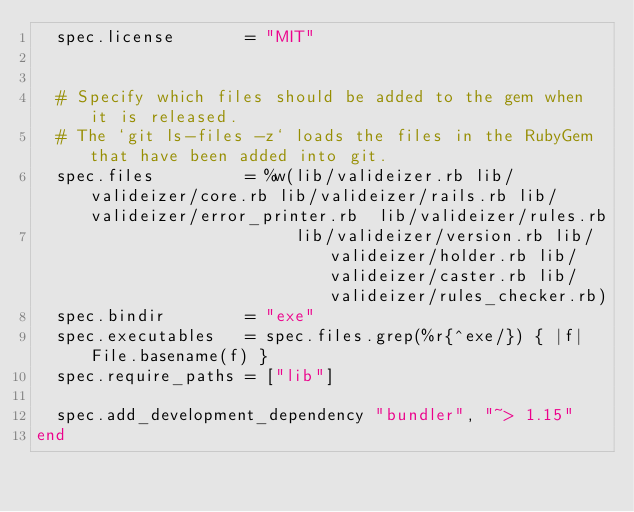<code> <loc_0><loc_0><loc_500><loc_500><_Ruby_>  spec.license       = "MIT"


  # Specify which files should be added to the gem when it is released.
  # The `git ls-files -z` loads the files in the RubyGem that have been added into git.
  spec.files         = %w(lib/valideizer.rb lib/valideizer/core.rb lib/valideizer/rails.rb lib/valideizer/error_printer.rb  lib/valideizer/rules.rb
                          lib/valideizer/version.rb lib/valideizer/holder.rb lib/valideizer/caster.rb lib/valideizer/rules_checker.rb)
  spec.bindir        = "exe"
  spec.executables   = spec.files.grep(%r{^exe/}) { |f| File.basename(f) }
  spec.require_paths = ["lib"]

  spec.add_development_dependency "bundler", "~> 1.15"
end
</code> 